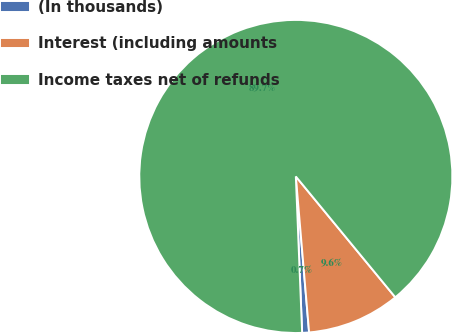Convert chart to OTSL. <chart><loc_0><loc_0><loc_500><loc_500><pie_chart><fcel>(In thousands)<fcel>Interest (including amounts<fcel>Income taxes net of refunds<nl><fcel>0.71%<fcel>9.61%<fcel>89.68%<nl></chart> 